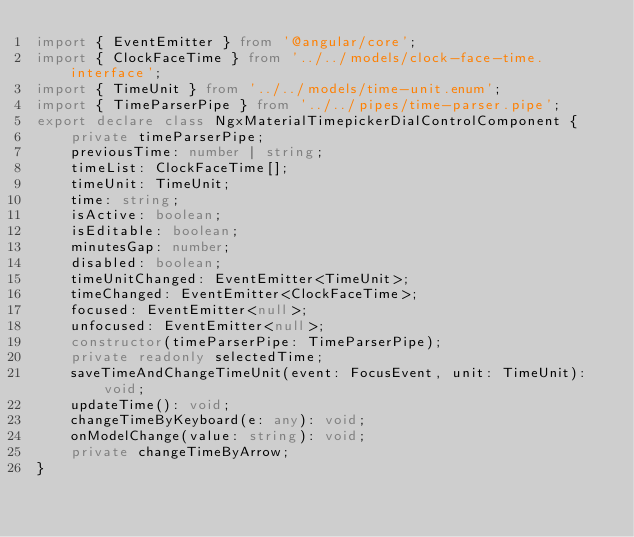<code> <loc_0><loc_0><loc_500><loc_500><_TypeScript_>import { EventEmitter } from '@angular/core';
import { ClockFaceTime } from '../../models/clock-face-time.interface';
import { TimeUnit } from '../../models/time-unit.enum';
import { TimeParserPipe } from '../../pipes/time-parser.pipe';
export declare class NgxMaterialTimepickerDialControlComponent {
    private timeParserPipe;
    previousTime: number | string;
    timeList: ClockFaceTime[];
    timeUnit: TimeUnit;
    time: string;
    isActive: boolean;
    isEditable: boolean;
    minutesGap: number;
    disabled: boolean;
    timeUnitChanged: EventEmitter<TimeUnit>;
    timeChanged: EventEmitter<ClockFaceTime>;
    focused: EventEmitter<null>;
    unfocused: EventEmitter<null>;
    constructor(timeParserPipe: TimeParserPipe);
    private readonly selectedTime;
    saveTimeAndChangeTimeUnit(event: FocusEvent, unit: TimeUnit): void;
    updateTime(): void;
    changeTimeByKeyboard(e: any): void;
    onModelChange(value: string): void;
    private changeTimeByArrow;
}
</code> 